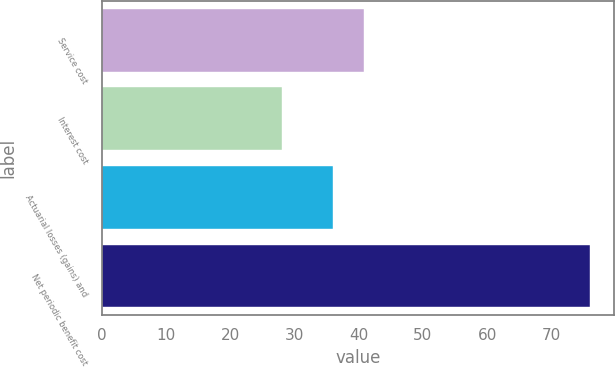<chart> <loc_0><loc_0><loc_500><loc_500><bar_chart><fcel>Service cost<fcel>Interest cost<fcel>Actuarial losses (gains) and<fcel>Net periodic benefit cost<nl><fcel>40.8<fcel>28<fcel>36<fcel>76<nl></chart> 